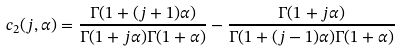<formula> <loc_0><loc_0><loc_500><loc_500>c _ { 2 } ( j , \alpha ) = \frac { \Gamma ( 1 + ( j + 1 ) \alpha ) } { \Gamma ( 1 + j \alpha ) \Gamma ( 1 + \alpha ) } - \frac { \Gamma ( 1 + j \alpha ) } { \Gamma ( 1 + ( j - 1 ) \alpha ) \Gamma ( 1 + \alpha ) }</formula> 